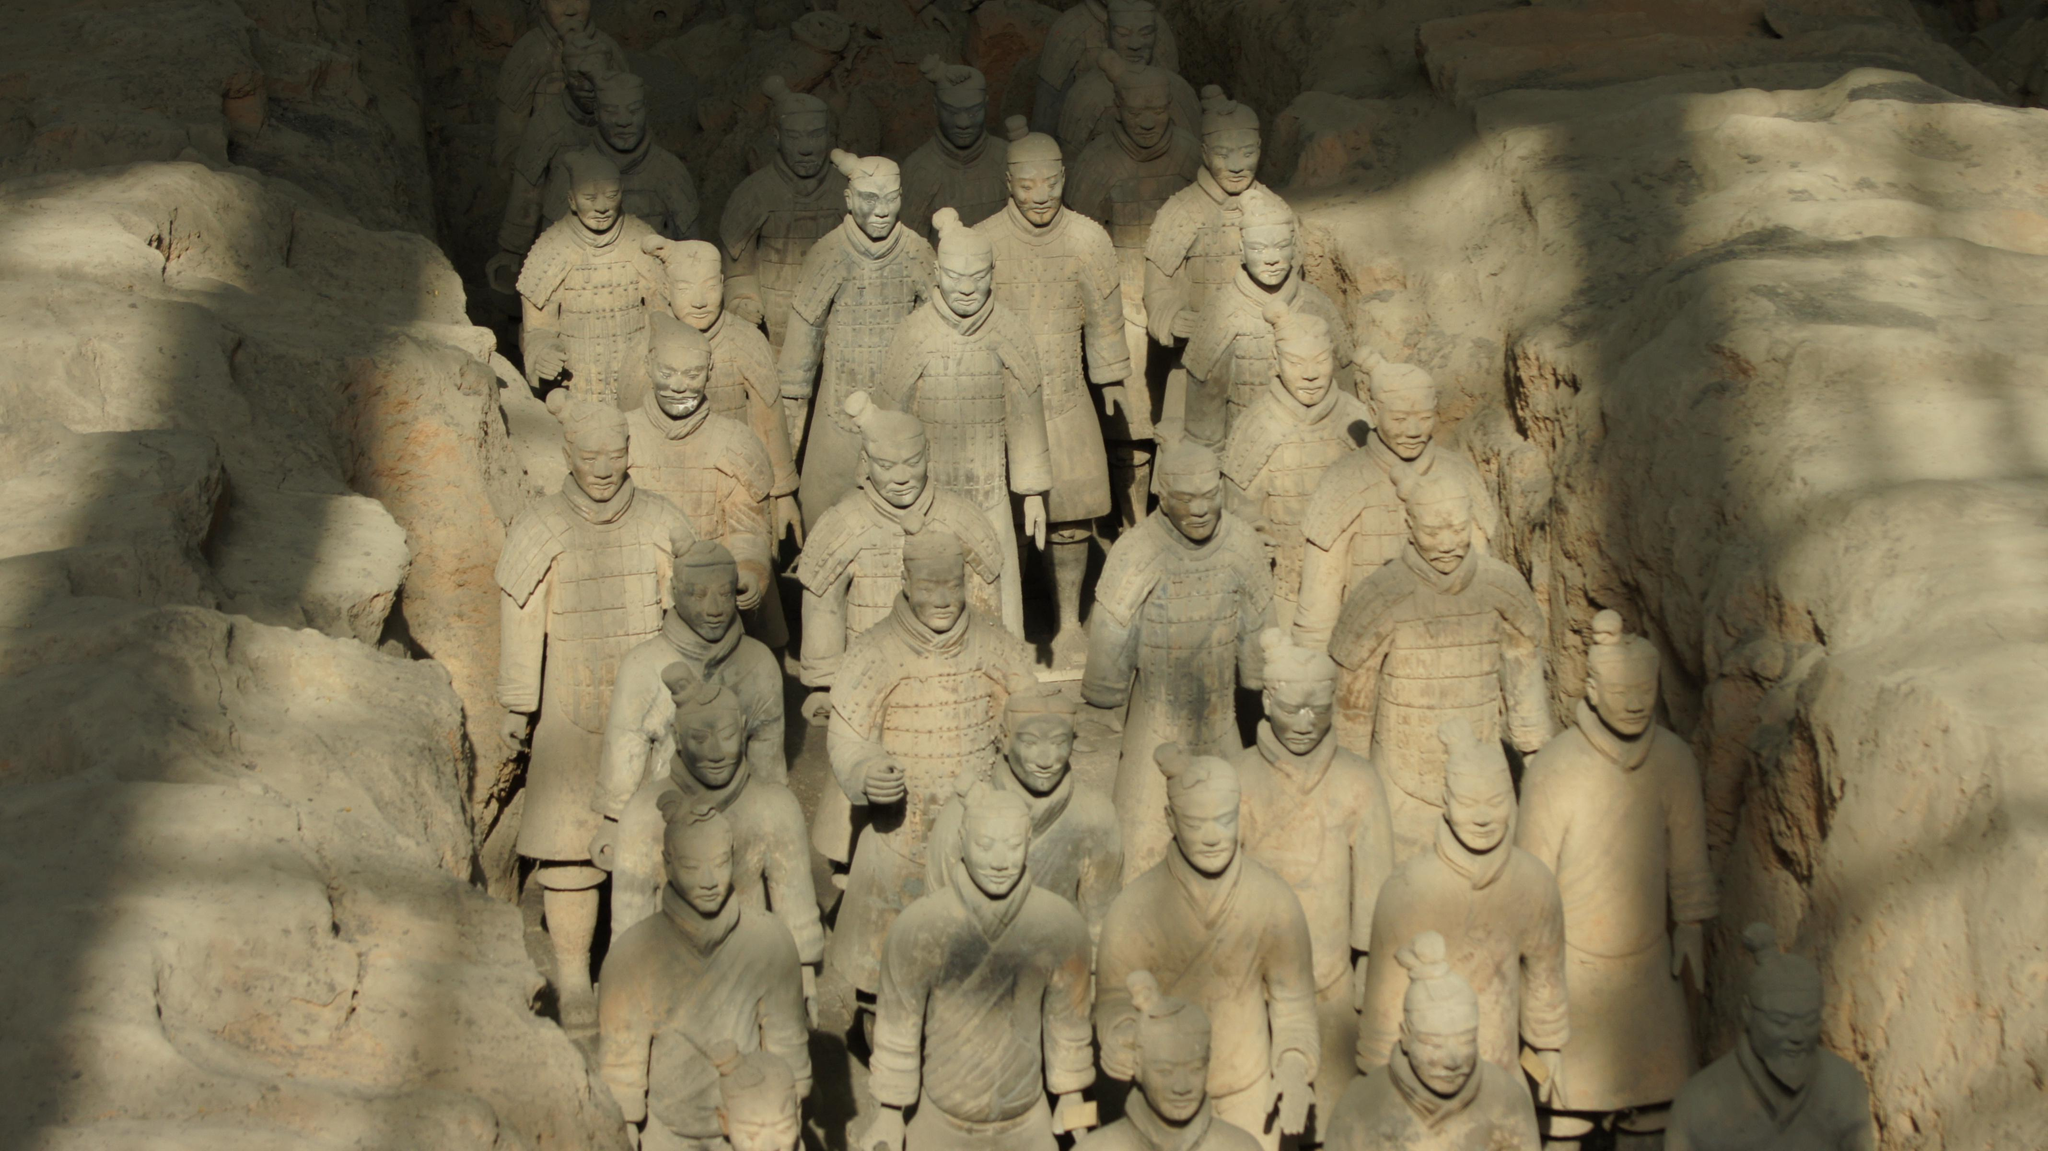What is the main subject of the image? The main subject of the image is a group of statues. Where are the statues located in the image? The statues are placed on the ground. How much money is being exchanged between the statues in the image? There is no money exchange depicted in the image, as it features a group of statues placed on the ground. What type of soup is being served by the statues in the image? There is no soup or any food item present in the image; it only features a group of statues. 